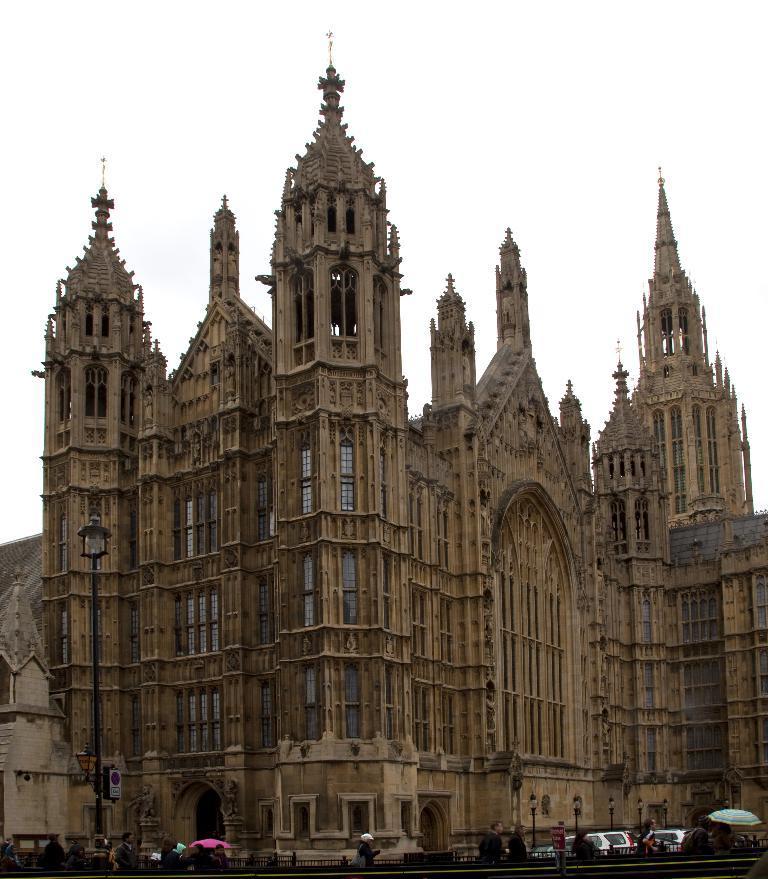Please provide a concise description of this image. In this image we can see buildings, street poles, street lights, advertisement boards, motor vehicles on the road, railings and persons walking on the road. In the background there is sky. 